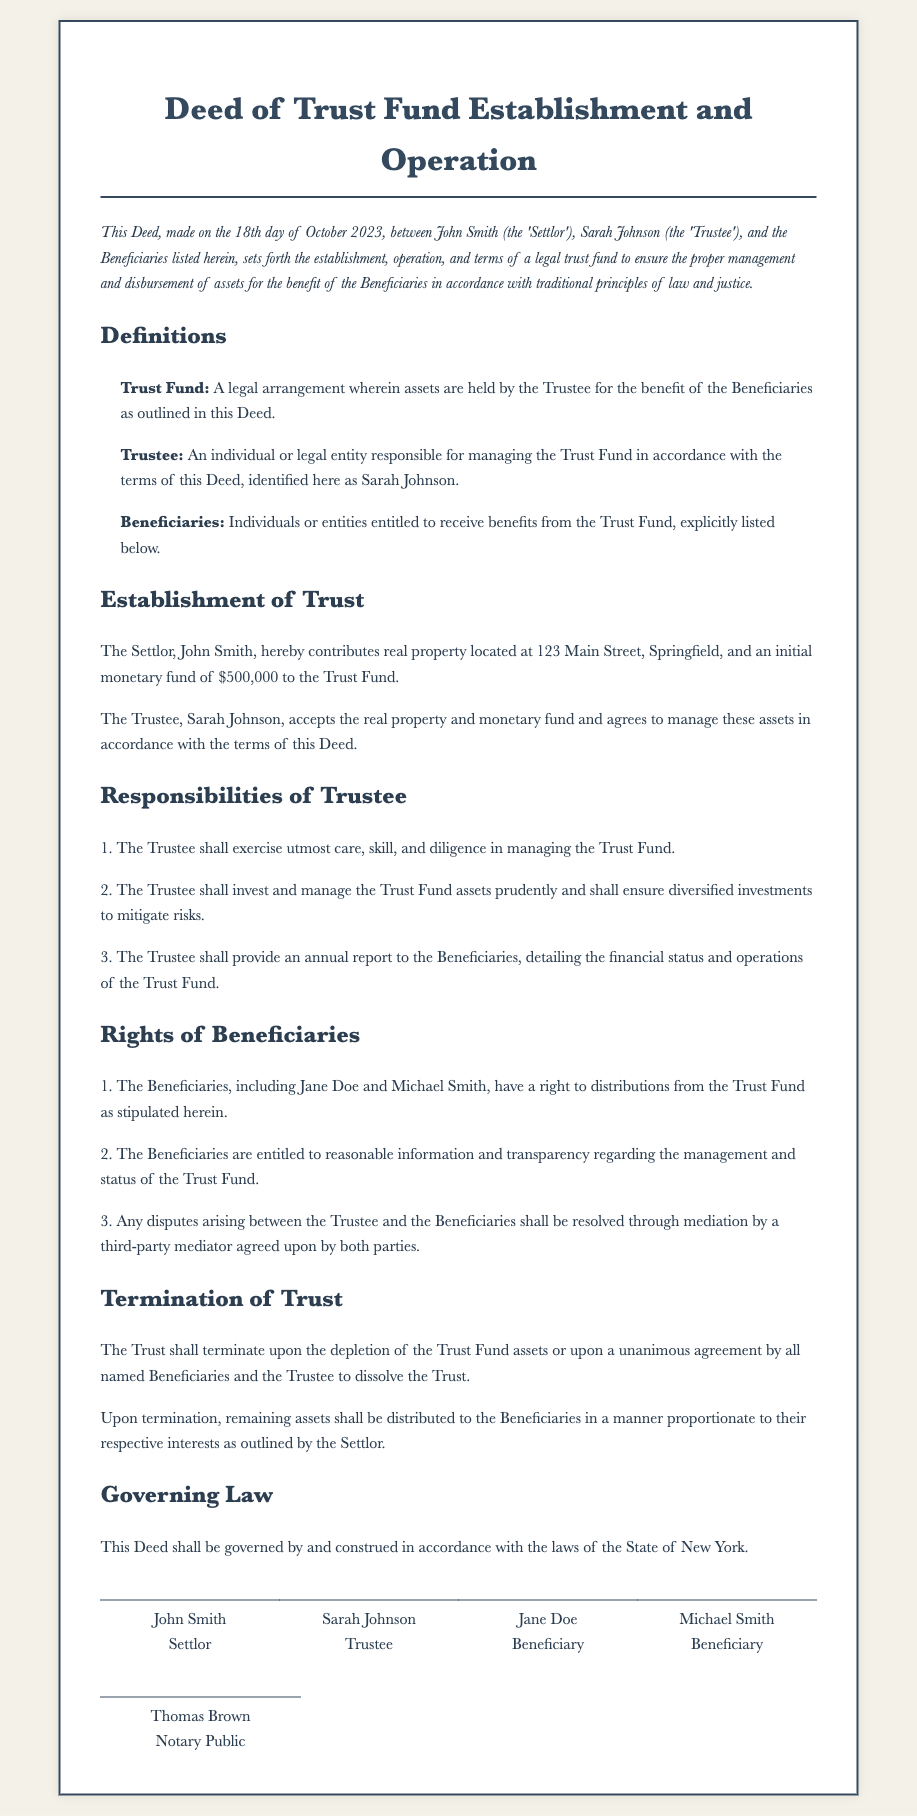What is the date of the agreement? The document states the agreement was made on the 18th day of October 2023.
Answer: 18th day of October 2023 Who is the Settlor? The Settlor is explicitly named in the document as John Smith.
Answer: John Smith What is the initial monetary fund contributed to the Trust Fund? The initial monetary fund specified in the document is $500,000.
Answer: $500,000 Who is responsible for managing the Trust Fund? The document identifies Sarah Johnson as the Trustee responsible for managing the Trust Fund.
Answer: Sarah Johnson What must the Trustee provide annually? The Trustee is required to provide an annual report to the Beneficiaries, detailing the financial status and operations of the Trust Fund.
Answer: Annual report What happens upon the depletion of the Trust Fund? The Trust shall terminate upon the depletion of the Trust Fund assets.
Answer: Terminate What is the governing law of this Deed? According to the document, this Deed is governed by the laws of the State of New York.
Answer: State of New York Who are the Beneficiaries listed in the document? The respective Beneficiaries named in the document are Jane Doe and Michael Smith.
Answer: Jane Doe and Michael Smith How can disputes be resolved between the Trustee and Beneficiaries? The document states that disputes shall be resolved through mediation by a third-party mediator agreed upon by both parties.
Answer: Mediation 